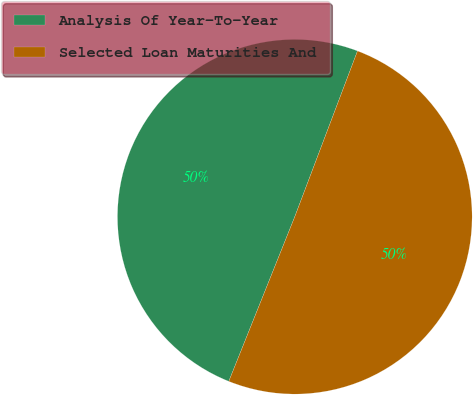Convert chart to OTSL. <chart><loc_0><loc_0><loc_500><loc_500><pie_chart><fcel>Analysis Of Year-To-Year<fcel>Selected Loan Maturities And<nl><fcel>49.69%<fcel>50.31%<nl></chart> 